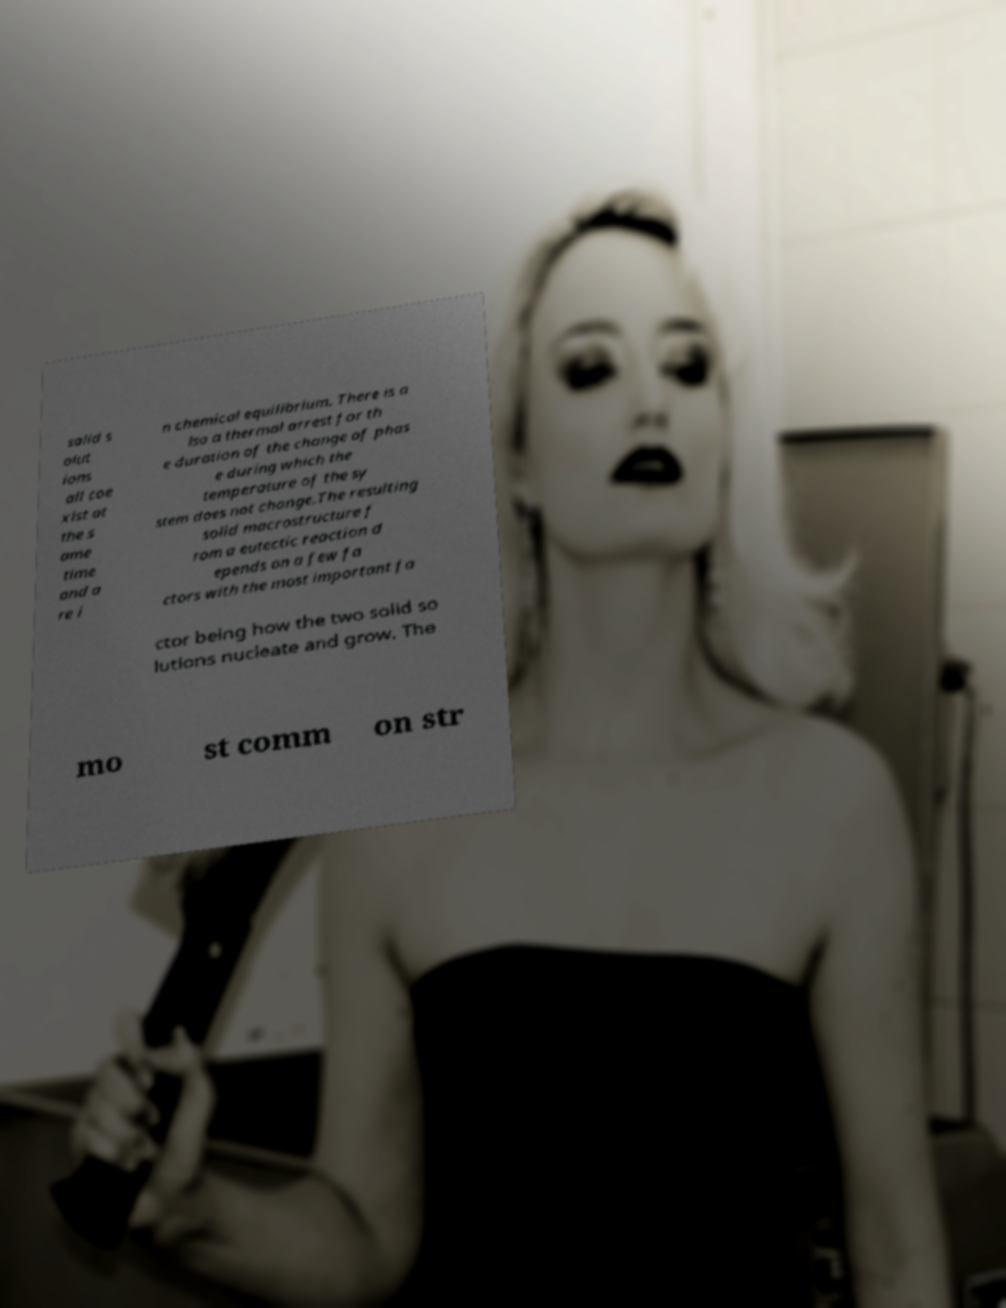I need the written content from this picture converted into text. Can you do that? solid s olut ions all coe xist at the s ame time and a re i n chemical equilibrium. There is a lso a thermal arrest for th e duration of the change of phas e during which the temperature of the sy stem does not change.The resulting solid macrostructure f rom a eutectic reaction d epends on a few fa ctors with the most important fa ctor being how the two solid so lutions nucleate and grow. The mo st comm on str 